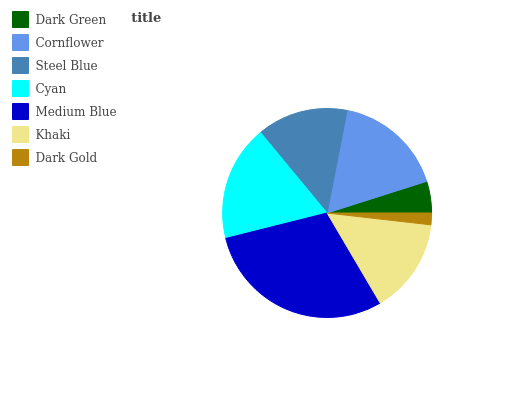Is Dark Gold the minimum?
Answer yes or no. Yes. Is Medium Blue the maximum?
Answer yes or no. Yes. Is Cornflower the minimum?
Answer yes or no. No. Is Cornflower the maximum?
Answer yes or no. No. Is Cornflower greater than Dark Green?
Answer yes or no. Yes. Is Dark Green less than Cornflower?
Answer yes or no. Yes. Is Dark Green greater than Cornflower?
Answer yes or no. No. Is Cornflower less than Dark Green?
Answer yes or no. No. Is Khaki the high median?
Answer yes or no. Yes. Is Khaki the low median?
Answer yes or no. Yes. Is Cornflower the high median?
Answer yes or no. No. Is Cornflower the low median?
Answer yes or no. No. 